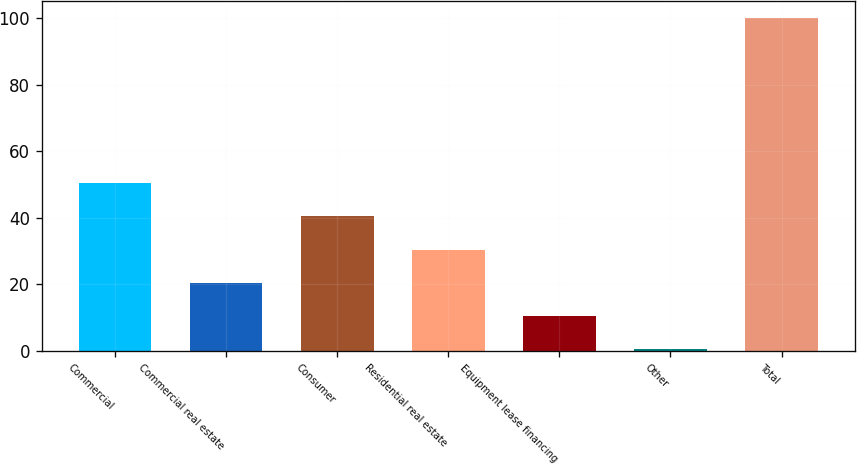<chart> <loc_0><loc_0><loc_500><loc_500><bar_chart><fcel>Commercial<fcel>Commercial real estate<fcel>Consumer<fcel>Residential real estate<fcel>Equipment lease financing<fcel>Other<fcel>Total<nl><fcel>50.3<fcel>20.48<fcel>40.36<fcel>30.42<fcel>10.54<fcel>0.6<fcel>100<nl></chart> 